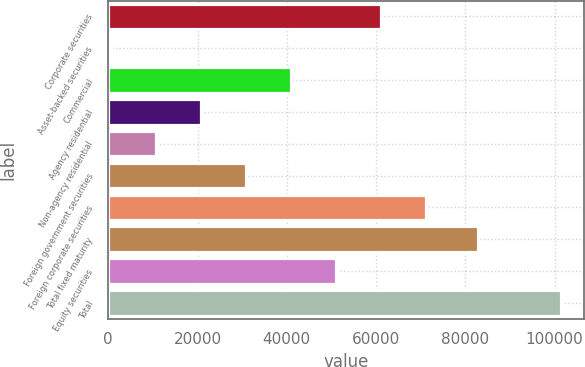Convert chart to OTSL. <chart><loc_0><loc_0><loc_500><loc_500><bar_chart><fcel>Corporate securities<fcel>Asset-backed securities<fcel>Commercial<fcel>Agency residential<fcel>Non-agency residential<fcel>Foreign government securities<fcel>Foreign corporate securities<fcel>Total fixed maturity<fcel>Equity securities<fcel>Total<nl><fcel>61112.2<fcel>550<fcel>40924.8<fcel>20737.4<fcel>10643.7<fcel>30831.1<fcel>71205.9<fcel>82737<fcel>51018.5<fcel>101487<nl></chart> 